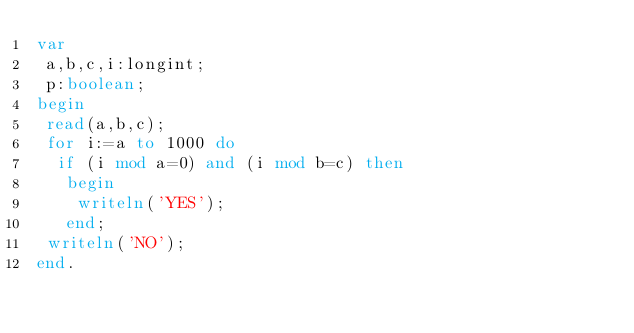<code> <loc_0><loc_0><loc_500><loc_500><_Pascal_>var
 a,b,c,i:longint;
 p:boolean;
begin
 read(a,b,c);
 for i:=a to 1000 do 
  if (i mod a=0) and (i mod b=c) then 
   begin 
    writeln('YES');
   end;
 writeln('NO');
end.
</code> 